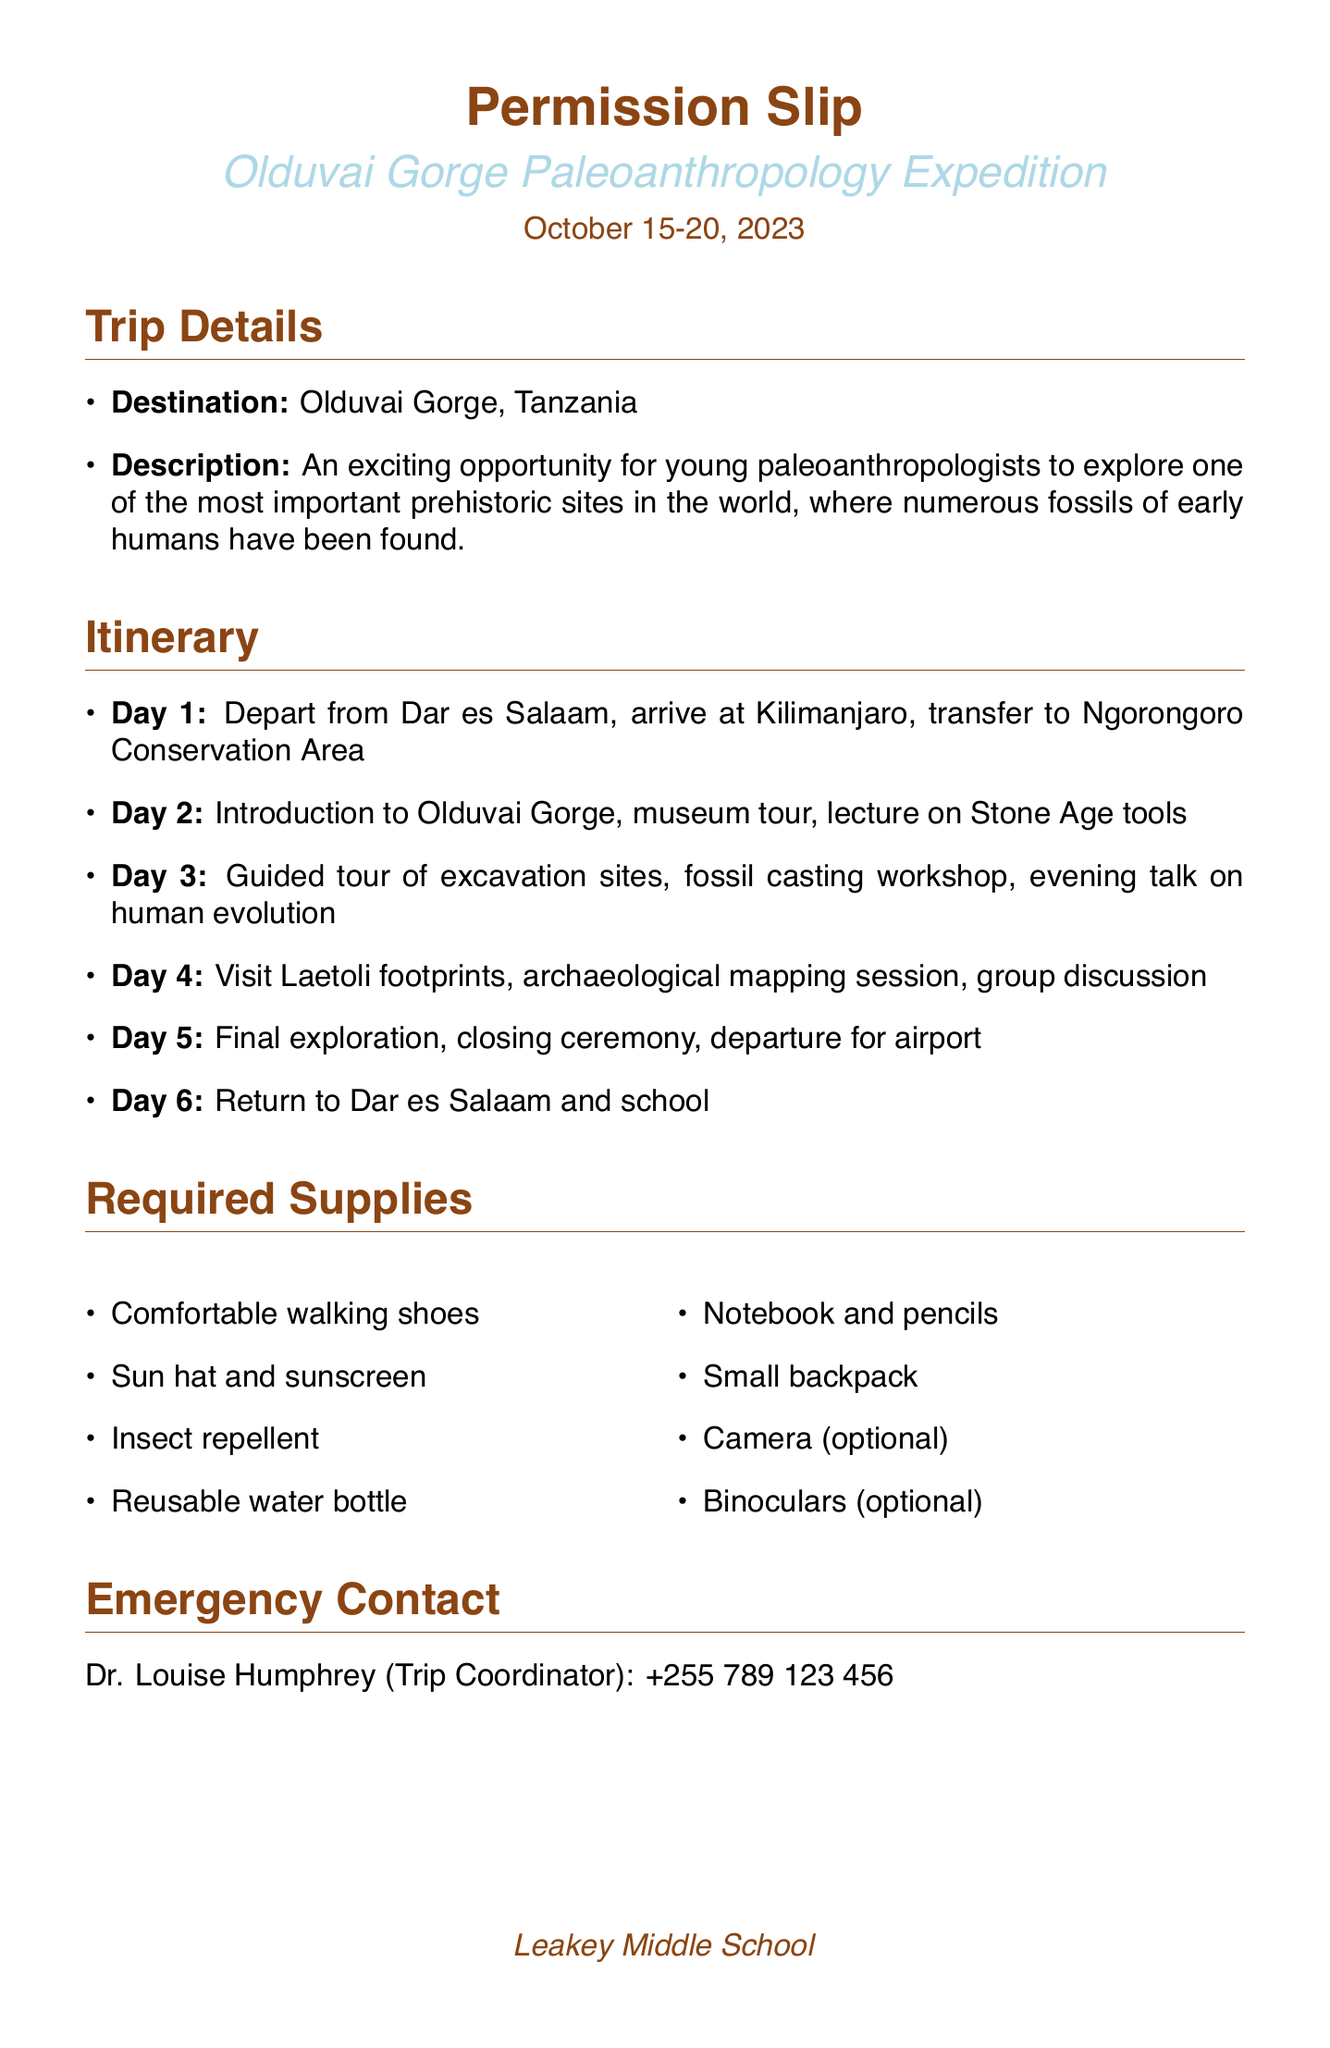What is the title of the field trip? The title of the field trip is stated in the document as "Olduvai Gorge Paleoanthropology Expedition."
Answer: Olduvai Gorge Paleoanthropology Expedition What are the dates of the trip? The trip dates are mentioned in the document as spanning from October 15 to October 20, 2023.
Answer: October 15-20, 2023 Who is the trip coordinator? The name of the trip coordinator is provided in the emergency contact section of the document, which is Dr. Louise Humphrey.
Answer: Dr. Louise Humphrey What is the total cost of the trip? The total cost is outlined in the cost details section of the document, with a total amount mentioned.
Answer: $2,500 What activity occurs on Day 3? The document lists various activities for each day; Day 3 includes a guided tour of excavation sites.
Answer: Guided tour of excavation sites Why is this trip significant for students? The document emphasizes that this field trip provides invaluable hands-on experience and inspiration for future studies in human evolution.
Answer: Invaluable hands-on experience What supplies are students required to bring? The required supplies section lists several items, including comfortable walking shoes as one of the essentials.
Answer: Comfortable walking shoes When is the payment deadline? The payment deadline for the trip is specified in the cost details section, which states September 1, 2023.
Answer: September 1, 2023 Are binoculars required for the trip? The required supplies section indicates that binoculars are optional, not required for the trip.
Answer: Optional 